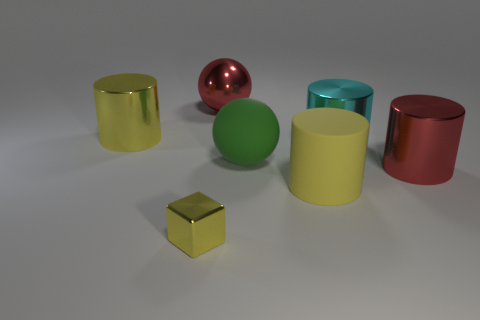Add 2 small purple metal cylinders. How many objects exist? 9 Subtract all cubes. How many objects are left? 6 Add 5 big red metal cylinders. How many big red metal cylinders exist? 6 Subtract 1 red spheres. How many objects are left? 6 Subtract all small cubes. Subtract all red balls. How many objects are left? 5 Add 7 large metal balls. How many large metal balls are left? 8 